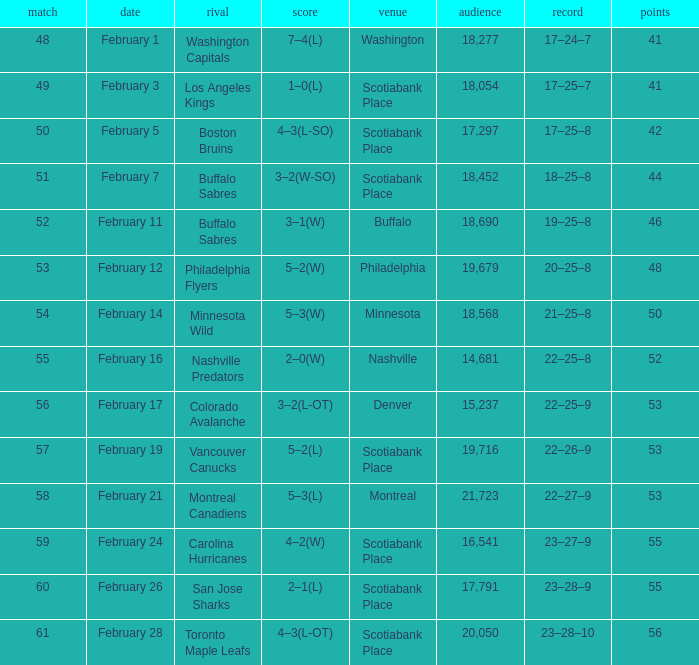What sum of game has an attendance of 18,690? 52.0. 